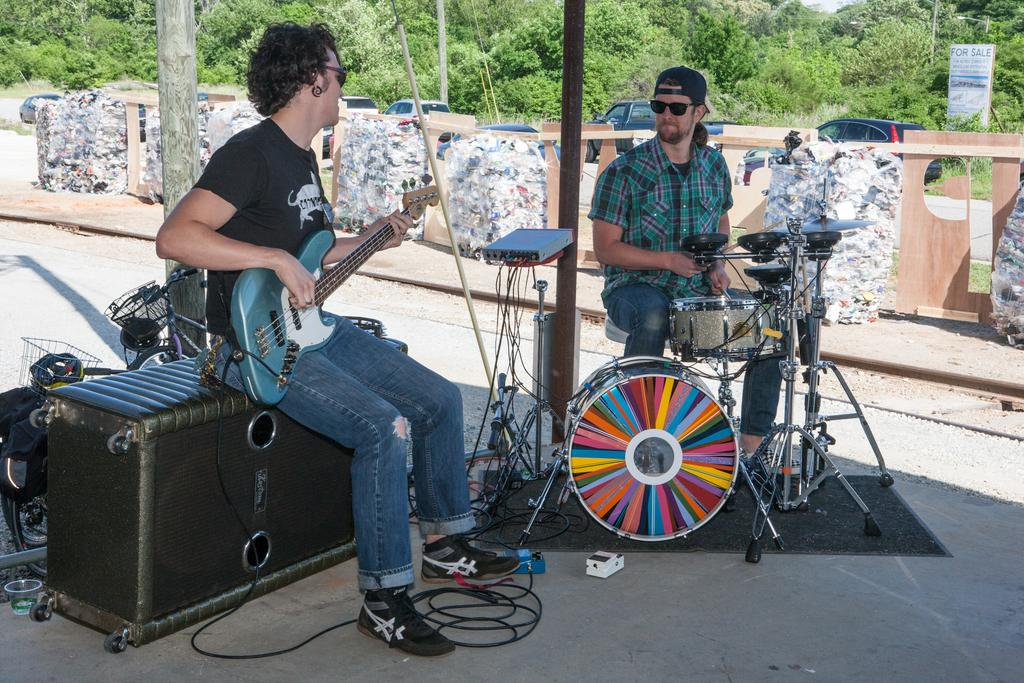What is the person on the left side of the image doing? The person on the left side of the image is sitting on a speaker and playing guitar. What is the person on the right side of the image doing? The person on the right side of the image is playing drums. What can be seen in the background of the image? There are trees and cars visible in the background of the image. What type of badge is the person wearing while playing the guitar? There is no badge visible on the person playing the guitar in the image. What hobbies does the fowl in the image enjoy? There are no fowl present in the image. 